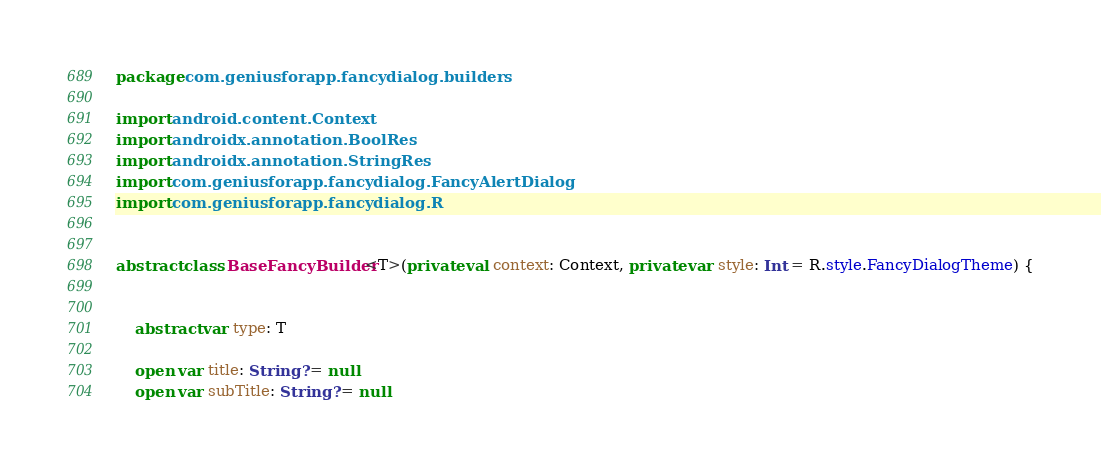Convert code to text. <code><loc_0><loc_0><loc_500><loc_500><_Kotlin_>package com.geniusforapp.fancydialog.builders

import android.content.Context
import androidx.annotation.BoolRes
import androidx.annotation.StringRes
import com.geniusforapp.fancydialog.FancyAlertDialog
import com.geniusforapp.fancydialog.R


abstract class BaseFancyBuilder<T>(private val context: Context, private var style: Int = R.style.FancyDialogTheme) {


    abstract var type: T

    open var title: String? = null
    open var subTitle: String? = null</code> 